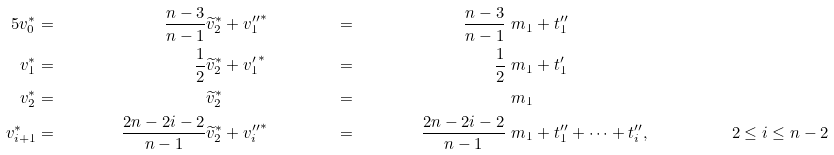Convert formula to latex. <formula><loc_0><loc_0><loc_500><loc_500>5 v _ { 0 } ^ { * } & = & \frac { n - 3 } { n - 1 } & \widetilde { v } _ { 2 } ^ { * } + { v _ { 1 } ^ { \prime \prime } } ^ { * } & & = & \frac { n - 3 } { n - 1 } & \ m _ { 1 } + t _ { 1 } ^ { \prime \prime } \\ v _ { 1 } ^ { * } & = & \frac { 1 } { 2 } & \widetilde { v } _ { 2 } ^ { * } + { v _ { 1 } ^ { \prime } } ^ { * } & & = & \frac { 1 } { 2 } & \ m _ { 1 } + t _ { 1 } ^ { \prime } \\ v _ { 2 } ^ { * } & = & & \widetilde { v } _ { 2 } ^ { * } & & = & & \ m _ { 1 } \\ v _ { i + 1 } ^ { * } & = & \frac { 2 n - 2 i - 2 } { n - 1 } & \widetilde { v } _ { 2 } ^ { * } + { v _ { i } ^ { \prime \prime } } ^ { * } & & = & \frac { 2 n - 2 i - 2 } { n - 1 } & \ m _ { 1 } + t _ { 1 } ^ { \prime \prime } + \cdots + t _ { i } ^ { \prime \prime } , \quad & & 2 \leq i \leq n - 2</formula> 